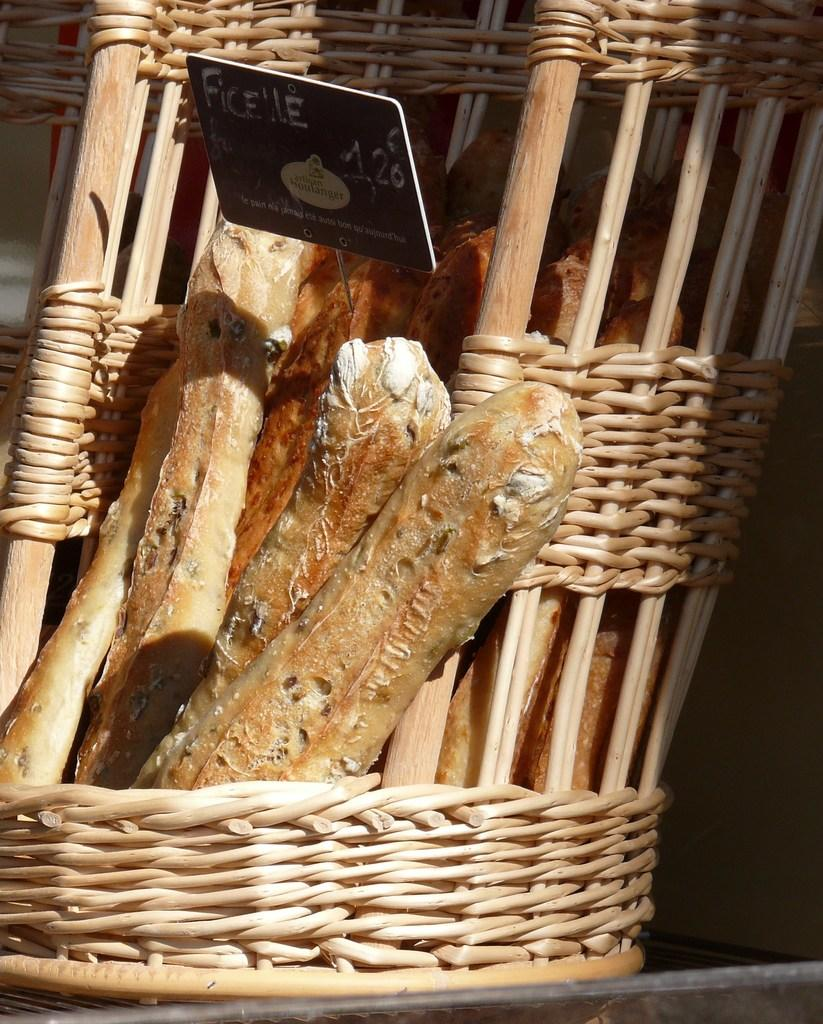What type of bread can be seen in the image? There are French bread loaves in the image. How are the bread loaves arranged or contained in the image? The bread loaves are in a basket. Is there any information about the cost of the bread in the image? Yes, there is a price tag associated with the basket. What type of action are the girls performing with the bread in the image? There are no girls present in the image, and therefore no action involving them can be observed. 